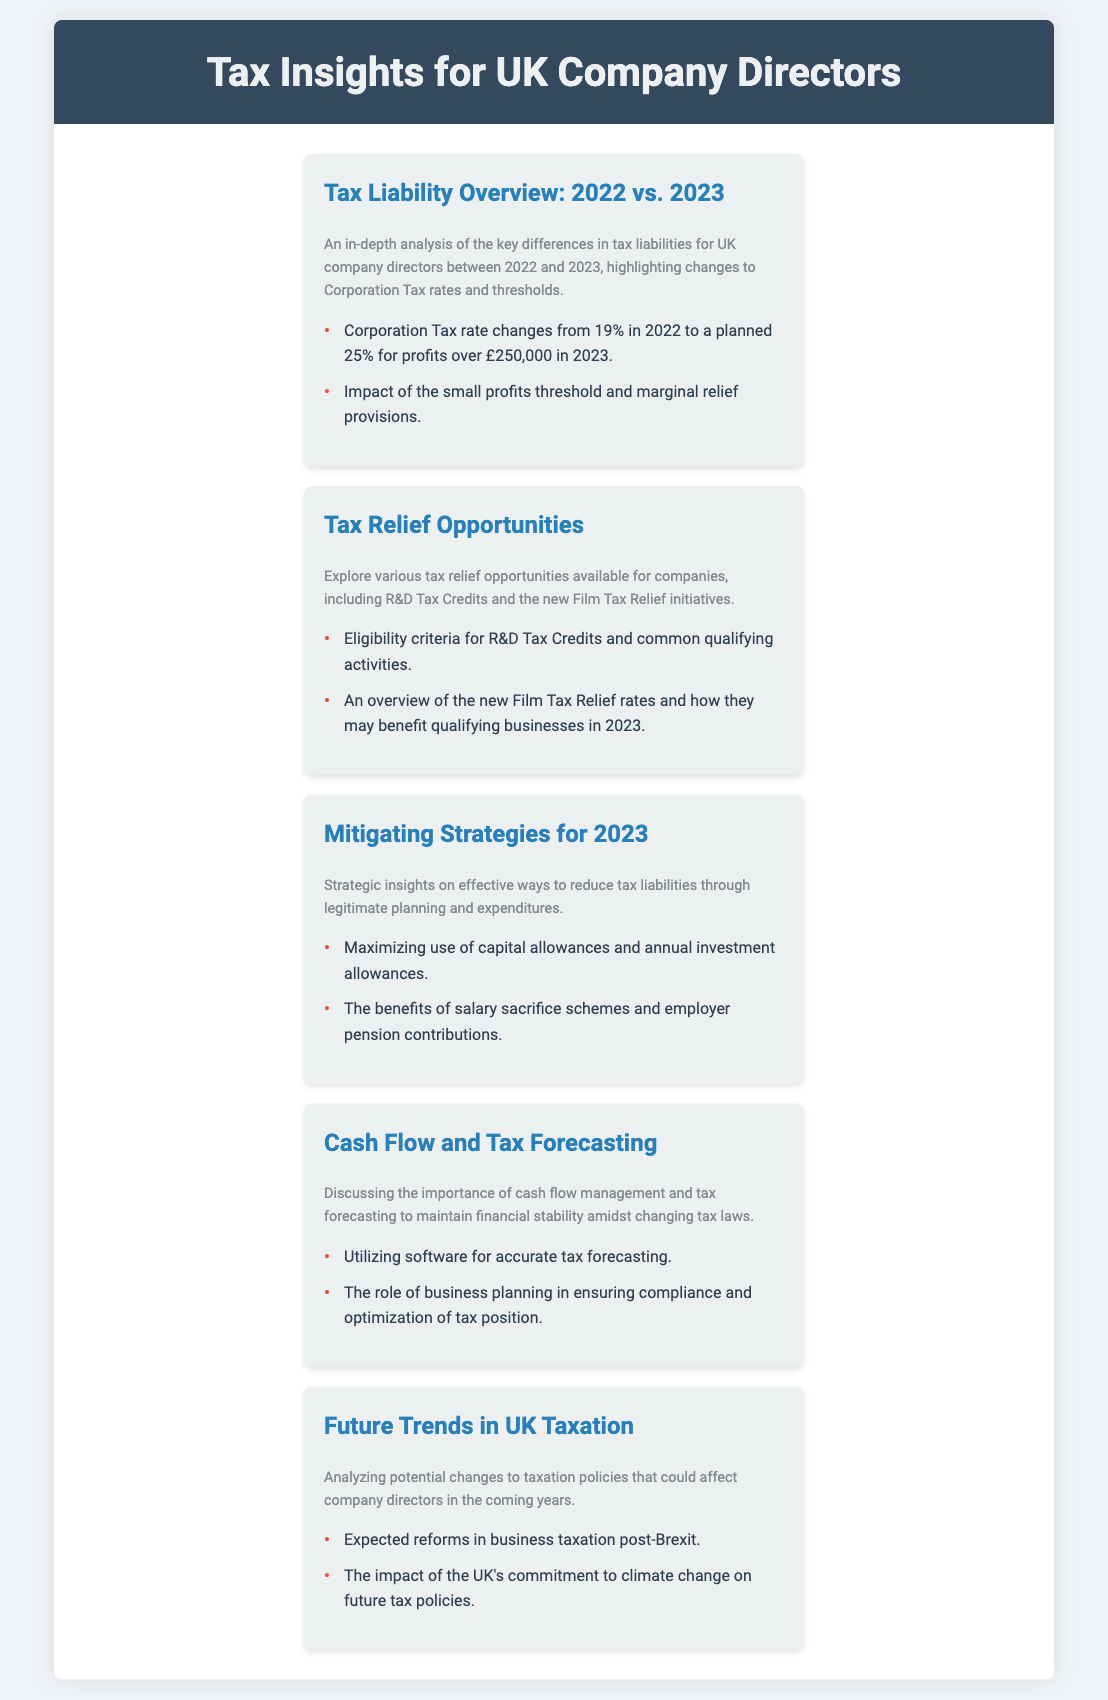What was the Corporation Tax rate in 2022? The document states the Corporation Tax rate was 19% in 2022.
Answer: 19% What is the planned Corporation Tax rate for profits over £250,000 in 2023? The planned Corporation Tax rate for 2023 is 25% for profits over £250,000.
Answer: 25% What tax relief is provided for research and development activities? The document mentions R&D Tax Credits as a tax relief opportunity for qualifying businesses.
Answer: R&D Tax Credits What benefit does salary sacrifice schemes offer? Salary sacrifice schemes can help reduce tax liabilities effectively through legitimate planning.
Answer: Reduce tax liabilities What are the expected reforms in business taxation related to? The document suggests expected reforms in business taxation are post-Brexit.
Answer: Post-Brexit What is the purpose of cash flow management mentioned in the document? Cash flow management is important for maintaining financial stability amidst changing tax laws.
Answer: Financial stability What initiative is highlighted as a new tax relief for 2023? The document highlights new Film Tax Relief initiatives as a tax relief for 2023.
Answer: Film Tax Relief What type of software is suggested for accurate tax forecasting? The document refers to utilizing software for accurate tax forecasting to manage finances effectively.
Answer: Software What should be maximized to reduce tax liabilities? The document suggests maximizing use of capital allowances and annual investment allowances.
Answer: Capital allowances 